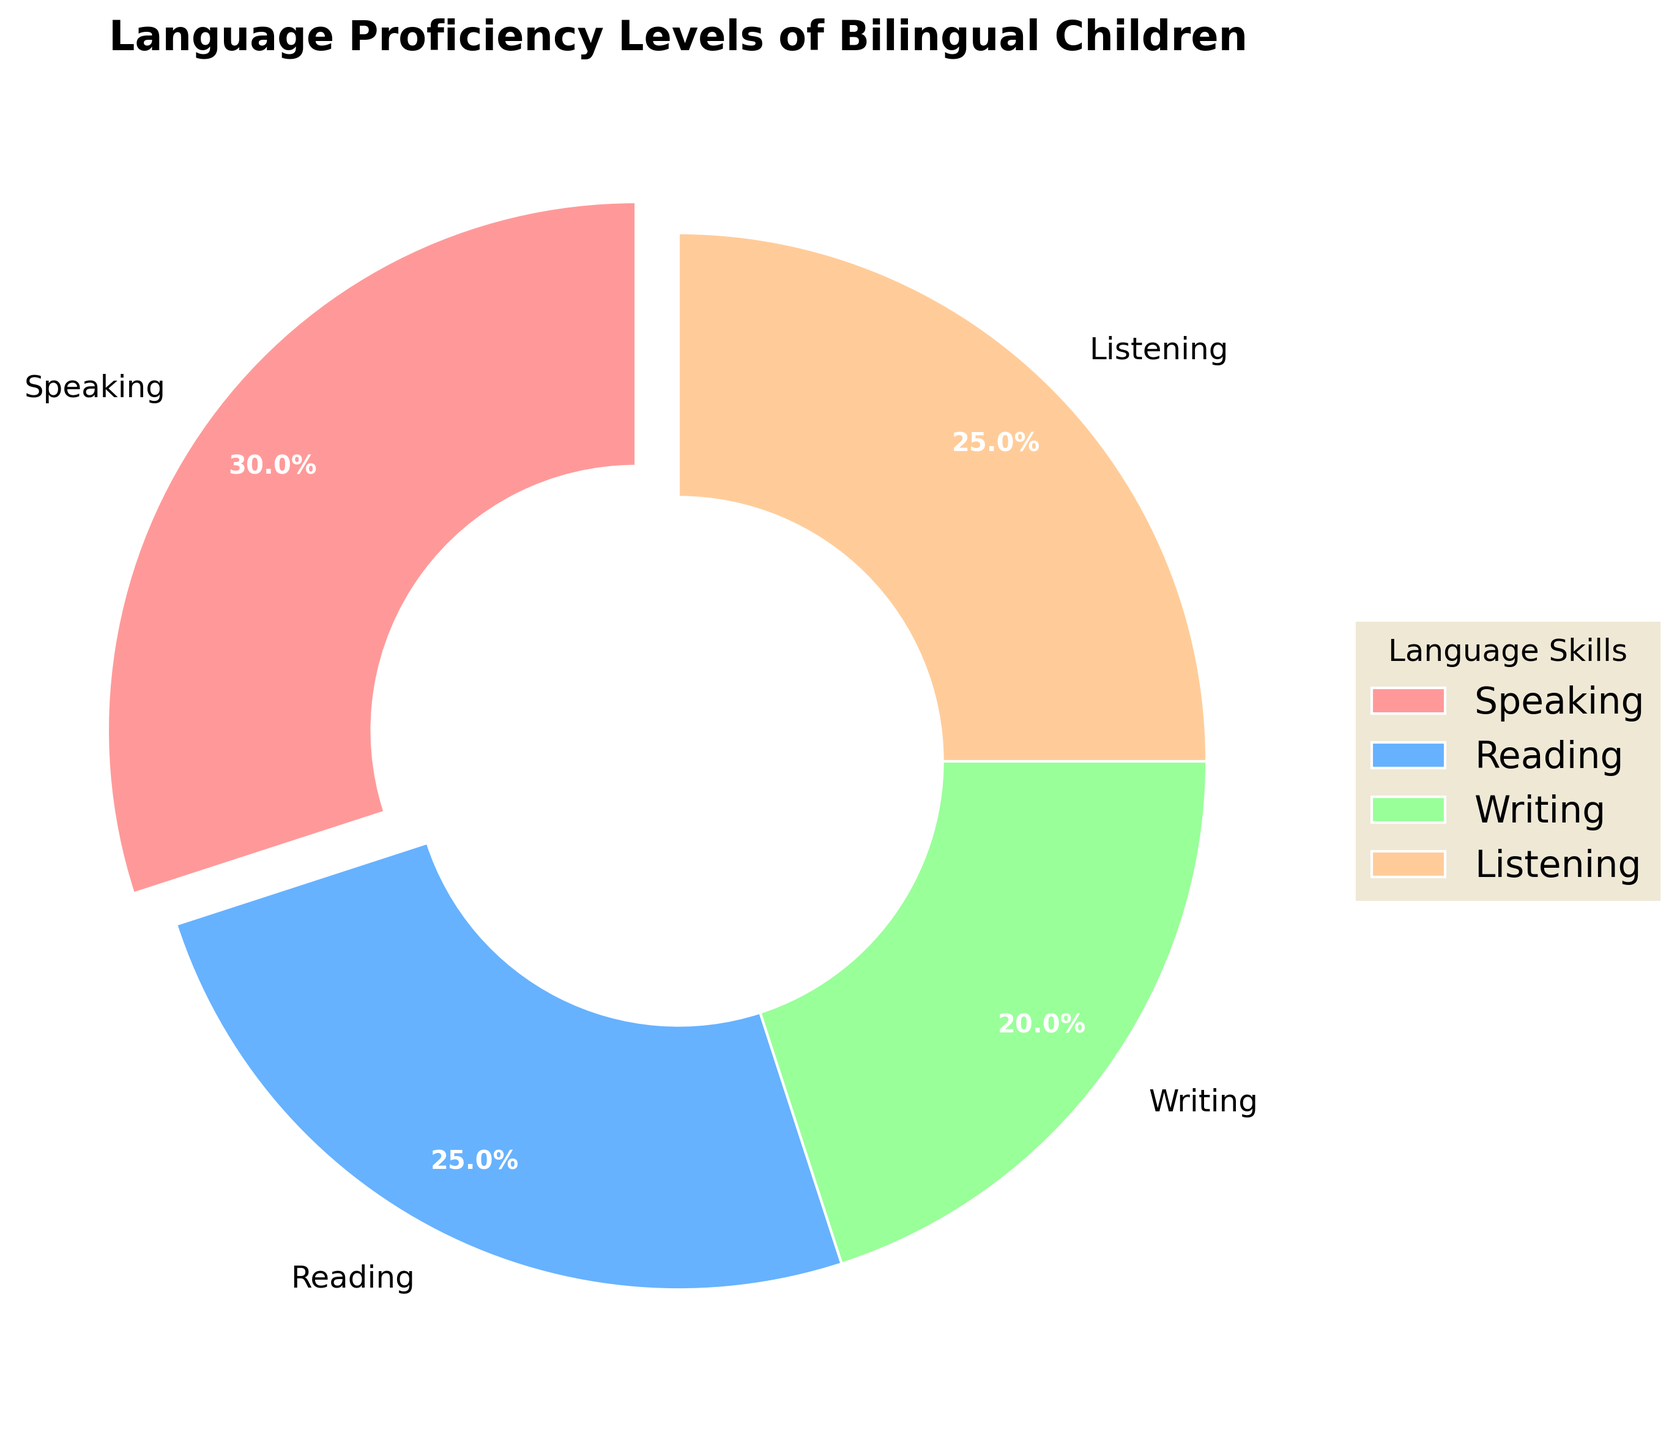What percentage of bilingual children are proficient in speaking? The pie chart shows that the speaking section comprises 30% of the total pie.
Answer: 30% Which two language skills have an equal percentage? By examining the pie chart, we see that both reading and listening skills each represent 25% of the pie.
Answer: Reading and listening Which language skill has the smallest percentage? Write has the smallest slice of the pie chart, representing 20%.
Answer: Writing What is the combined percentage of proficiency in speaking and writing? Speaking is 30% and writing is 20%. Adding these two percentages together gives 30% + 20% = 50%.
Answer: 50% What is the difference in percentage between speaking and reading proficiency? Speaking has a percentage of 30%, and reading has a percentage of 25%. The difference between them is 30% - 25% = 5%.
Answer: 5% Which segment of the pie chart is exploded, and what percentage does it represent? The speaking segment is exploded, and it represents 30% of the pie.
Answer: Speaking, 30% What is the average percentage of proficiency for all the language skills represented? Adding the percentages for speaking, reading, writing, and listening gives 30% + 25% + 20% + 25% = 100%. Dividing by the number of skills (4) gives 100% / 4 = 25%.
Answer: 25% Is the segment representing listening proficiency larger, smaller, or equal in size to the segment representing writing proficiency? The listening segment is larger than the writing segment (25% compared to 20%).
Answer: Larger How many language skills have a proficiency level lower than 30%? Both reading (25%) and writing (20%) have proficiency levels lower than 30%. That makes 2 skills.
Answer: Two What visual attribute distinguishes the speaking proficiency segment from the other segments? The segment representing speaking proficiency is distinguished by being "exploded" or offset from the rest of the pie chart.
Answer: Exploded segment 